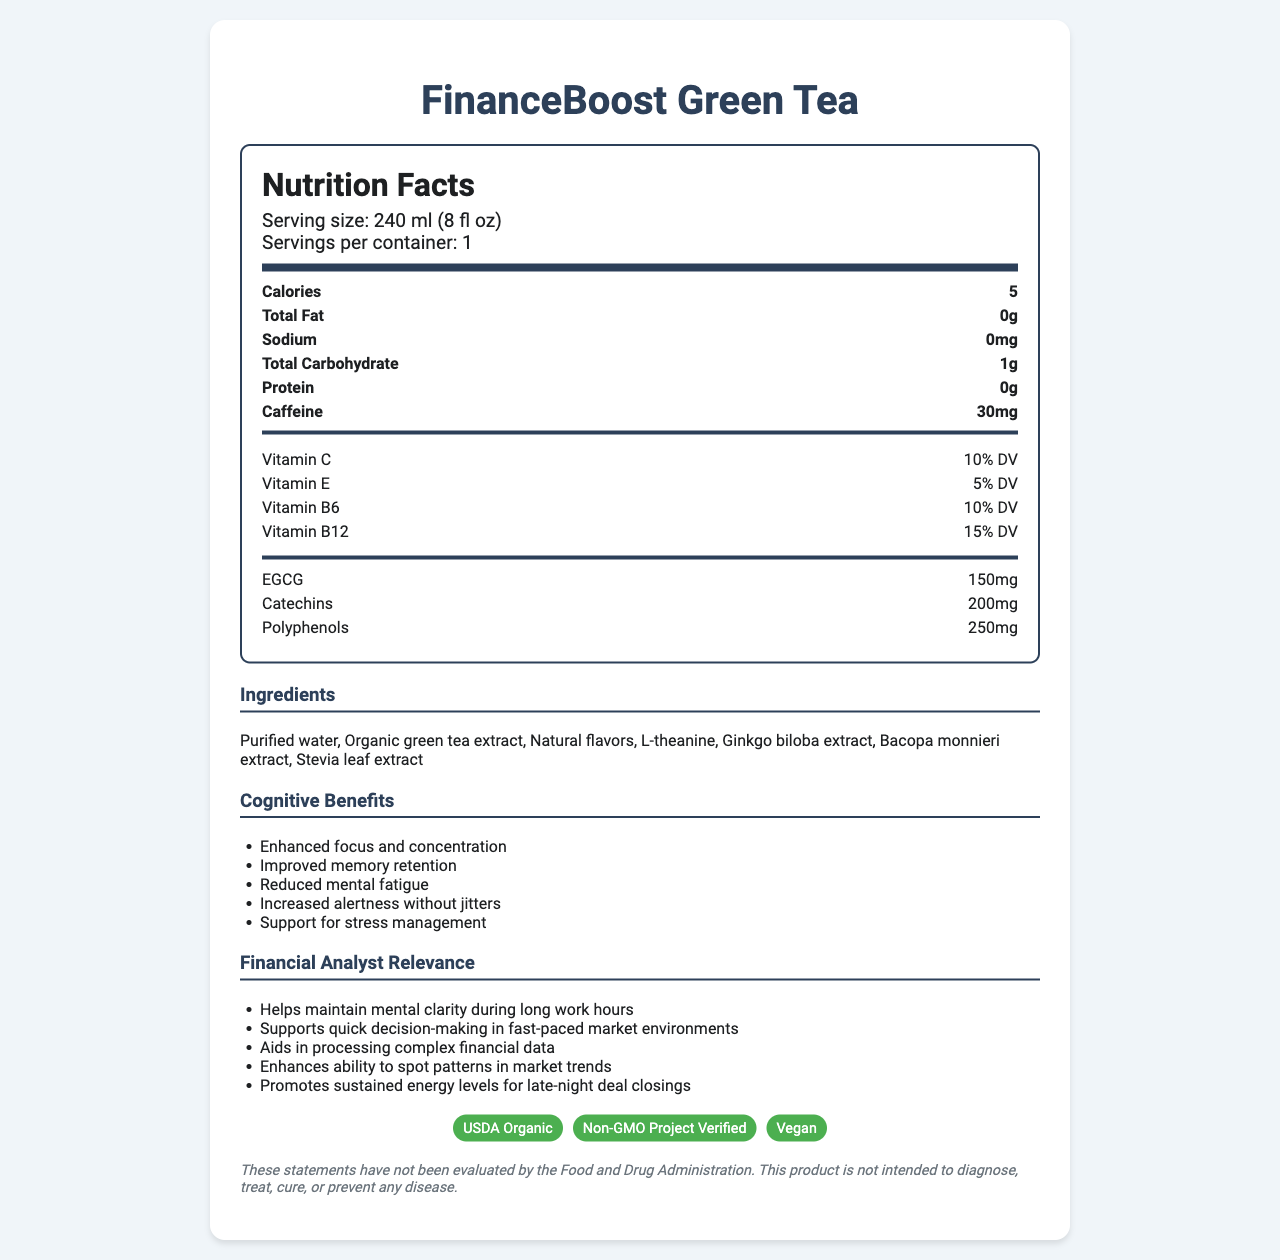What is the serving size for FinanceBoost Green Tea? The document explicitly states the serving size at the beginning of the nutrition facts section.
Answer: 240 ml (8 fl oz) How much caffeine is in one serving of FinanceBoost Green Tea? The caffeine content is listed under the nutrition items section.
Answer: 30mg Name two vitamins found in FinanceBoost Green Tea and their daily values (DV). The vitamins and their daily values are detailed under the "Vitamins and Minerals" section.
Answer: Vitamin C: 10% DV, Vitamin B12: 15% DV What are three cognitive benefits of consuming FinanceBoost Green Tea? The cognitive benefits are listed in the "Cognitive Benefits" section of the document.
Answer: Enhanced focus and concentration, Improved memory retention, Reduced mental fatigue What is the main source of sweetness in FinanceBoost Green Tea? The ingredient list includes Stevia leaf extract as the source of sweetness.
Answer: Stevia leaf extract Which of the following is a certification received by FinanceBoost Green Tea? 
A. Fair Trade Certified
B. USDA Organic
C. Rainforest Alliance The certification badges at the bottom of the document include USDA Organic.
Answer: B. USDA Organic What is the total amount of calories in one serving of FinanceBoost Green Tea? 
I. 0 
II. 5 
III. 10 The calories content is explicitly stated as 5 calories in the nutrition facts.
Answer: II. 5 Does FinanceBoost Green Tea contain any protein? The nutrition facts section shows that the protein amount is 0g.
Answer: No Summarize the main idea of the document. The document provides details about the nutritional content, cognitive benefits, and relevance to financial analysts, along with usage instructions and certifications.
Answer: FinanceBoost Green Tea is an antioxidant-rich beverage designed to support cognitive functions and provide mental clarity for financial analysts. It is low in calories, contains beneficial vitamins and minerals, and includes ingredients known for cognitive benefits. The product is USDA Organic, Non-GMO, and Vegan-certified. Can you determine the price of FinanceBoost Green Tea from the document? The document does not provide any details regarding the price of the product.
Answer: Not enough information 